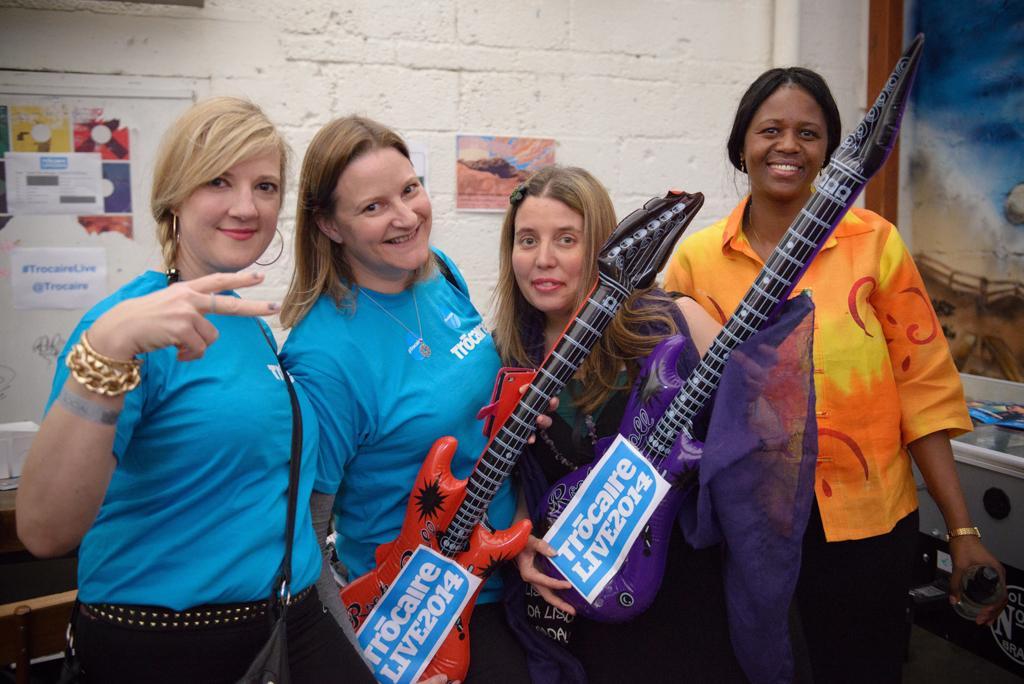In one or two sentences, can you explain what this image depicts? This 4 woman's are standing and giving stills. This 2 women are holding a guitar. On wall there are different type of posters. This woman is holding a bottle. 